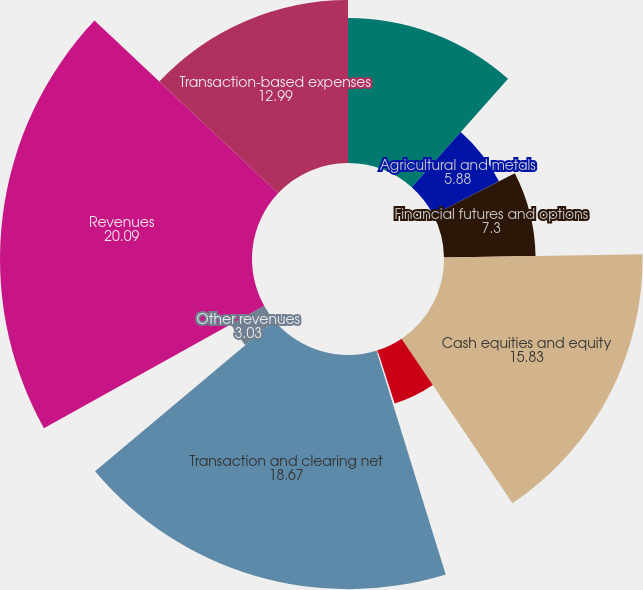Convert chart to OTSL. <chart><loc_0><loc_0><loc_500><loc_500><pie_chart><fcel>Energy futures and options<fcel>Agricultural and metals<fcel>Financial futures and options<fcel>Cash equities and equity<fcel>Fixed income and credit<fcel>OTC and other transactions<fcel>Transaction and clearing net<fcel>Other revenues<fcel>Revenues<fcel>Transaction-based expenses<nl><fcel>11.56%<fcel>5.88%<fcel>7.3%<fcel>15.83%<fcel>4.46%<fcel>0.19%<fcel>18.67%<fcel>3.03%<fcel>20.09%<fcel>12.99%<nl></chart> 